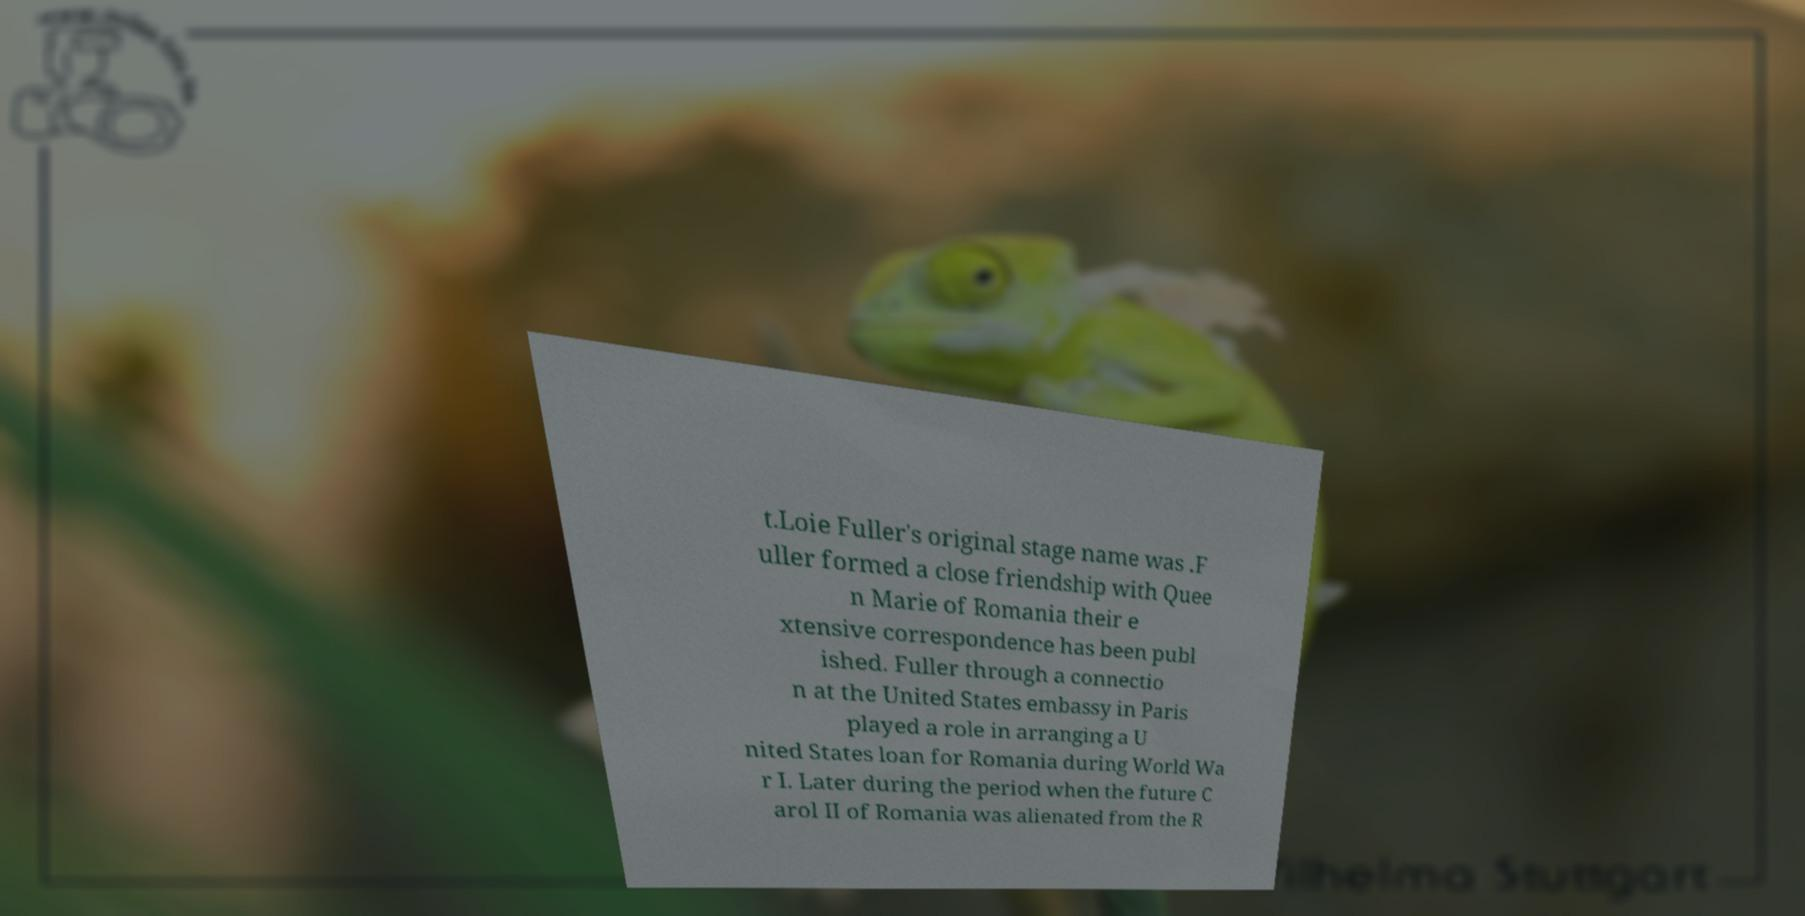There's text embedded in this image that I need extracted. Can you transcribe it verbatim? t.Loie Fuller's original stage name was .F uller formed a close friendship with Quee n Marie of Romania their e xtensive correspondence has been publ ished. Fuller through a connectio n at the United States embassy in Paris played a role in arranging a U nited States loan for Romania during World Wa r I. Later during the period when the future C arol II of Romania was alienated from the R 